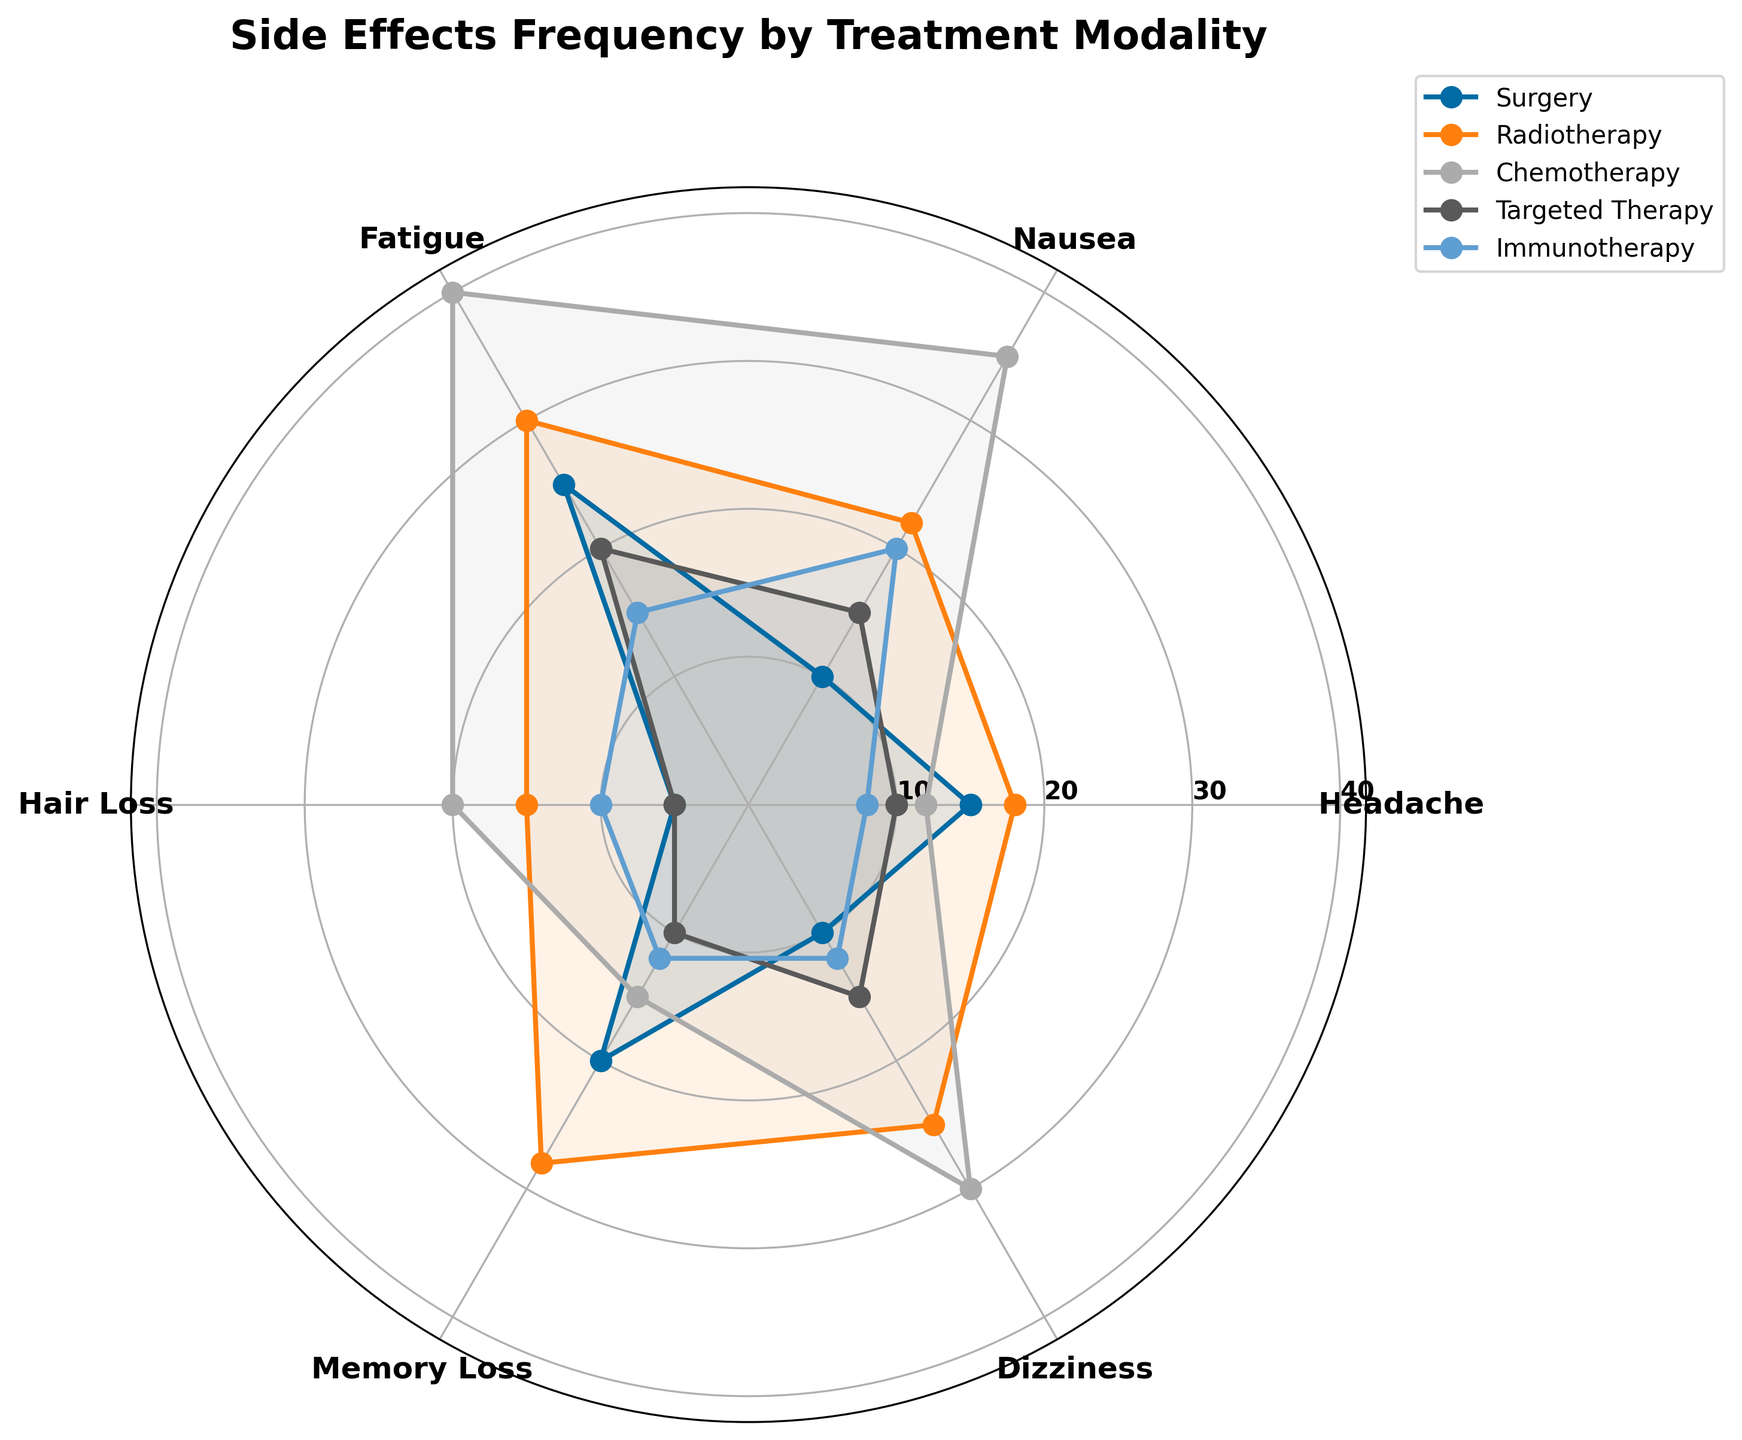What is the title of the radar chart? The title is located above the plot and typically summarizes the content or purpose of the chart. Here, it's stated at the top of the radar chart.
Answer: Side Effects Frequency by Treatment Modality What are the side effects measured in the radar chart? To identify the side effects, look at the labels around the circumference of the radar chart. These labels represent the different categories of side effects.
Answer: Headache, Nausea, Fatigue, Hair Loss, Memory Loss, Dizziness Which treatment modality has the highest frequency of Fatigue? To find this, locate the section of the radar chart labeled "Fatigue" and identify the treatment that extends furthest away from the center in that section.
Answer: Chemotherapy What is the average frequency of Headache for all treatments? Calculate the average by adding the frequencies of Headache for all treatments and dividing by the number of treatments. \( (15 + 18 + 12 + 10 + 8) / 5 = 12.6 \)
Answer: 12.6 Which treatment modality shows the least side effects on average across all categories? To determine this, calculate the average frequency of all side effects for each treatment modality and then identify the treatment with the smallest value.
Answer: Immunotherapy Compare the frequency of Nausea between Chemotherapy and Radiotherapy. Which one is higher and by how much? Look at the frequencies for Nausea in both Chemotherapy and Radiotherapy, then subtract the smaller value from the larger value. \( 35 (Chemotherapy) - 22 (Radiotherapy) = 13 \)
Answer: Chemotherapy by 13 Which side effect has the greatest variance in frequency among all treatment options? To find this, calculate the variance for each side effect across all treatments and identify the one with the highest variance. The values are as follows: Headache (10), Nausea (25), Fatigue (15), Hair Loss (15), Memory Loss (18), Dizziness (20). Hence, Nausea has the greatest variance.
Answer: Nausea What is the frequency of Memory Loss for Targeted Therapy? Locate the radial line labeled "Memory Loss" and see where the line for Targeted Therapy intersects this axis.
Answer: 10 Across all treatments, which side effect is reported least frequently overall? Sum the frequency values for each side effect across all treatments and identify the one with the lowest total sum.
Answer: Hair Loss How does the frequency of Dizziness in Surgery compare to Immunotherapy? Check the values of Dizziness for both Surgery and Immunotherapy and perform a comparison. \( 10 (Surgery) - 12 (Immunotherapy) = -2 \). This implies Immunotherapy has a higher frequency by 2.
Answer: Immunotherapy is higher by 2 